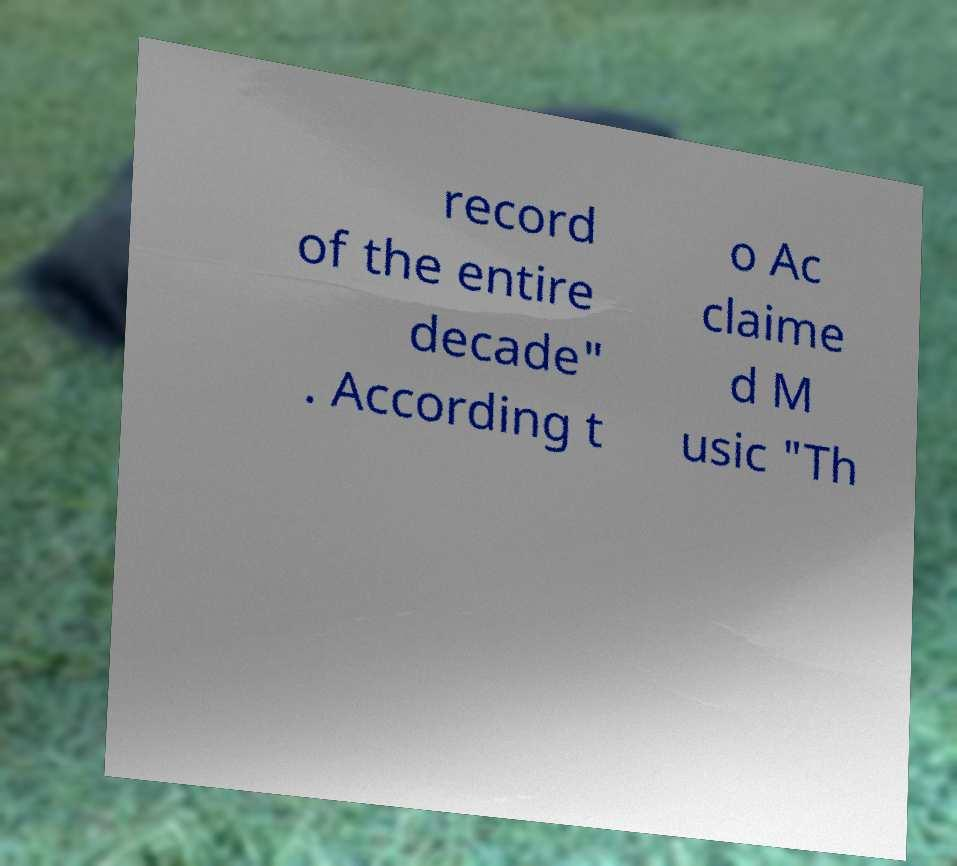Could you assist in decoding the text presented in this image and type it out clearly? record of the entire decade" . According t o Ac claime d M usic "Th 